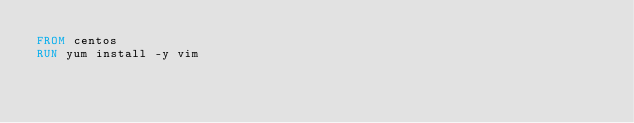Convert code to text. <code><loc_0><loc_0><loc_500><loc_500><_Dockerfile_>FROM centos
RUN yum install -y vim</code> 